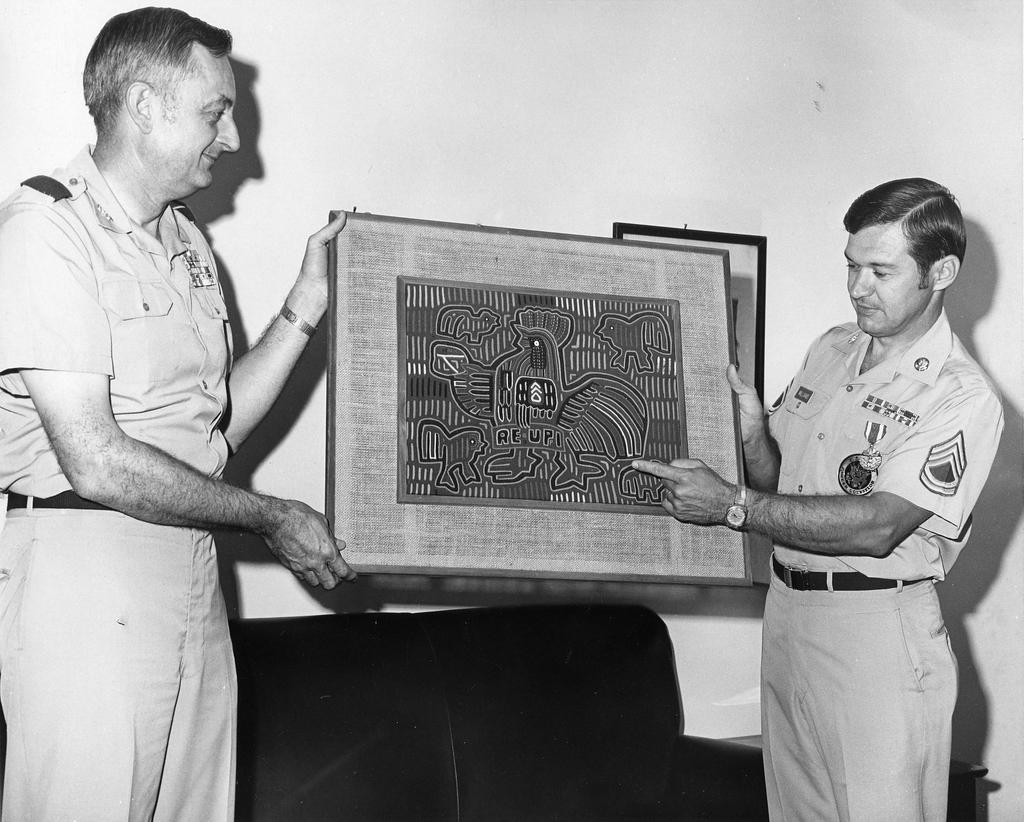What is the color scheme of the image? The image is black and white. What are the people in the image doing? The people in the image are holding objects. Can you describe the wall in the image? There is a wall with a frame in the image. What type of furniture is present in the image? There is a sofa in the image. What is the unspecified object in the image? Unfortunately, the facts provided do not specify the nature of the unspecified object. What type of stew is being prepared in the image? There is no indication of any stew or cooking activity in the image. How does the wind affect the objects in the image? The image is not outdoors, and there is no indication of wind or its effects on the objects in the image. 